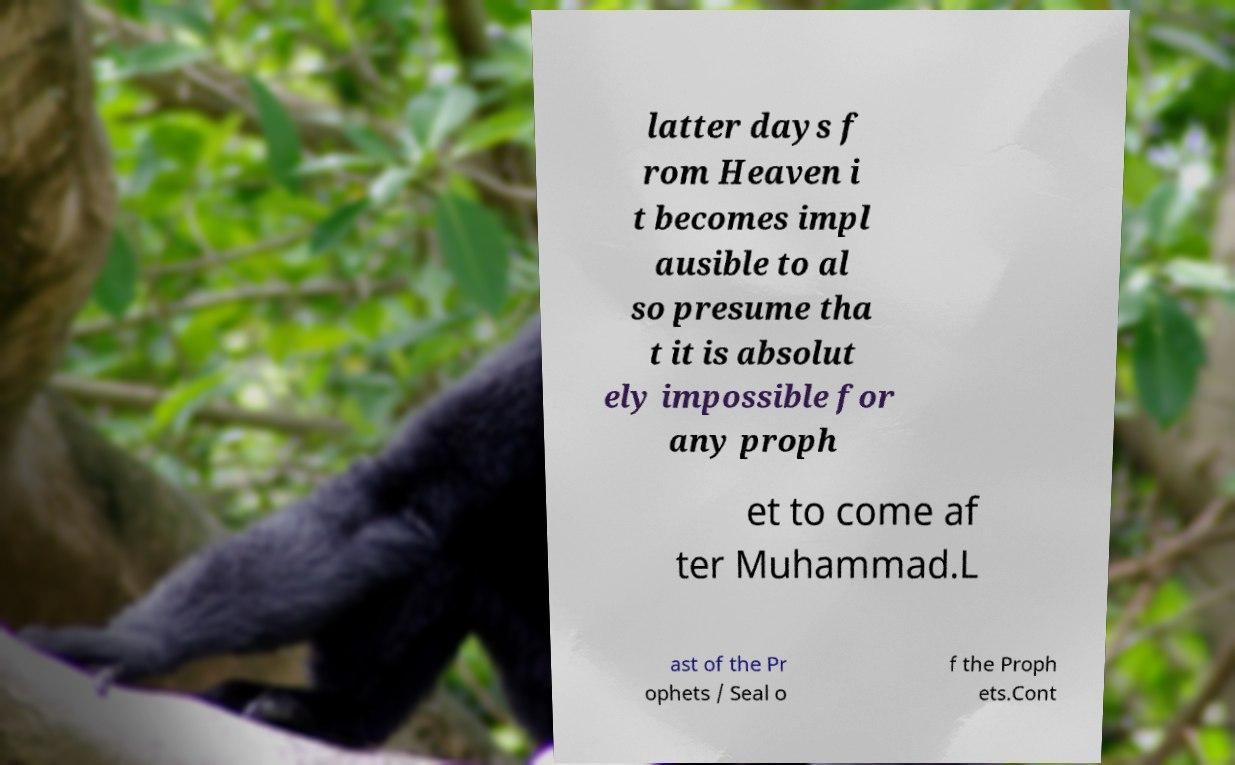Could you assist in decoding the text presented in this image and type it out clearly? latter days f rom Heaven i t becomes impl ausible to al so presume tha t it is absolut ely impossible for any proph et to come af ter Muhammad.L ast of the Pr ophets / Seal o f the Proph ets.Cont 